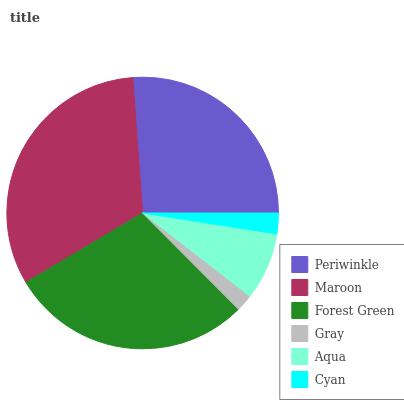Is Gray the minimum?
Answer yes or no. Yes. Is Maroon the maximum?
Answer yes or no. Yes. Is Forest Green the minimum?
Answer yes or no. No. Is Forest Green the maximum?
Answer yes or no. No. Is Maroon greater than Forest Green?
Answer yes or no. Yes. Is Forest Green less than Maroon?
Answer yes or no. Yes. Is Forest Green greater than Maroon?
Answer yes or no. No. Is Maroon less than Forest Green?
Answer yes or no. No. Is Periwinkle the high median?
Answer yes or no. Yes. Is Aqua the low median?
Answer yes or no. Yes. Is Aqua the high median?
Answer yes or no. No. Is Forest Green the low median?
Answer yes or no. No. 